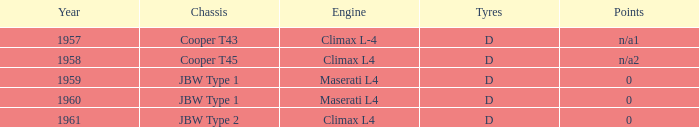What company built the chassis for a year later than 1959 and a climax l4 engine? JBW Type 2. 